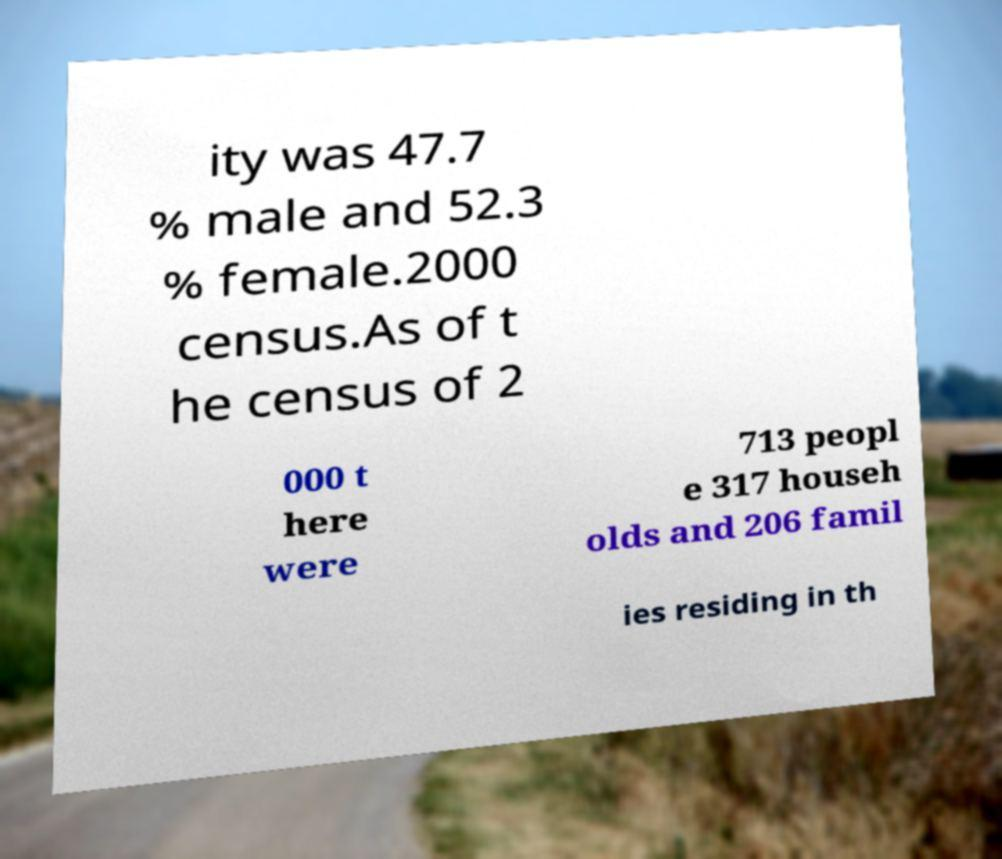Can you read and provide the text displayed in the image?This photo seems to have some interesting text. Can you extract and type it out for me? ity was 47.7 % male and 52.3 % female.2000 census.As of t he census of 2 000 t here were 713 peopl e 317 househ olds and 206 famil ies residing in th 